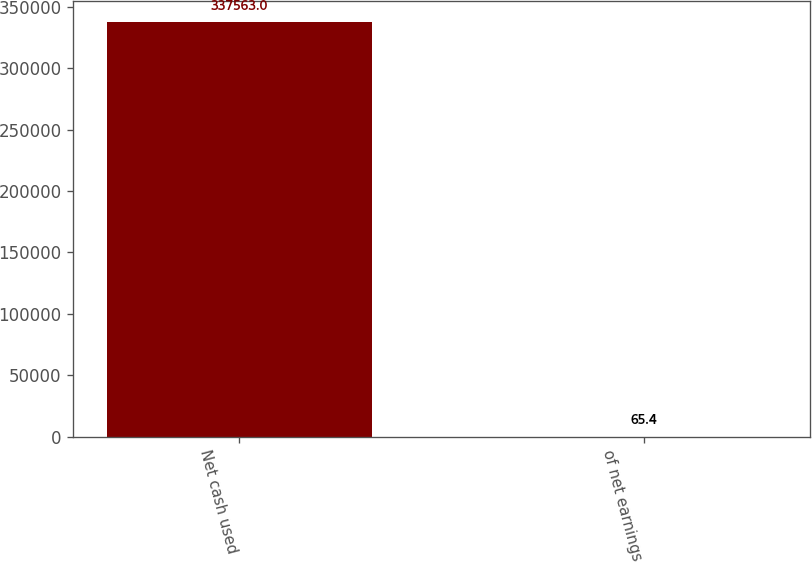Convert chart to OTSL. <chart><loc_0><loc_0><loc_500><loc_500><bar_chart><fcel>Net cash used<fcel>of net earnings<nl><fcel>337563<fcel>65.4<nl></chart> 